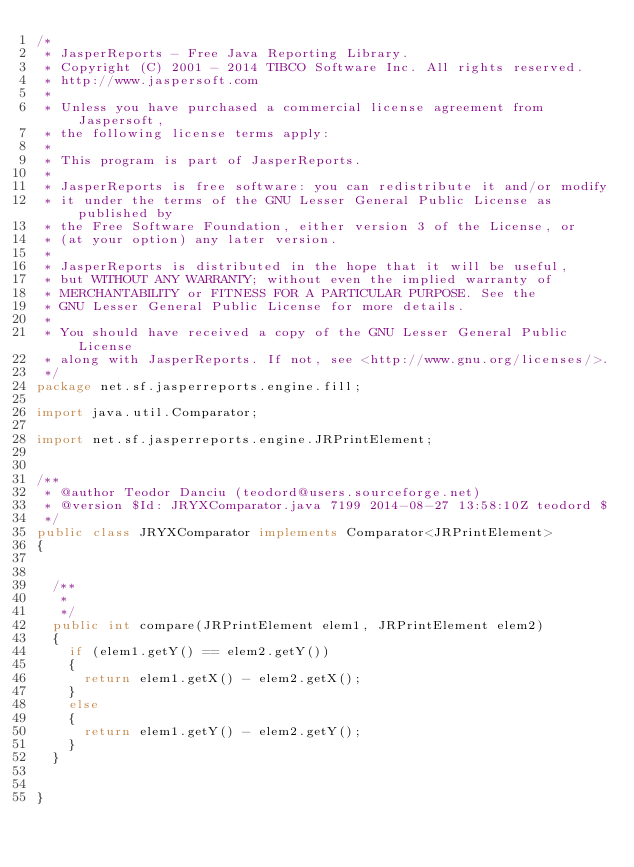Convert code to text. <code><loc_0><loc_0><loc_500><loc_500><_Java_>/*
 * JasperReports - Free Java Reporting Library.
 * Copyright (C) 2001 - 2014 TIBCO Software Inc. All rights reserved.
 * http://www.jaspersoft.com
 *
 * Unless you have purchased a commercial license agreement from Jaspersoft,
 * the following license terms apply:
 *
 * This program is part of JasperReports.
 *
 * JasperReports is free software: you can redistribute it and/or modify
 * it under the terms of the GNU Lesser General Public License as published by
 * the Free Software Foundation, either version 3 of the License, or
 * (at your option) any later version.
 *
 * JasperReports is distributed in the hope that it will be useful,
 * but WITHOUT ANY WARRANTY; without even the implied warranty of
 * MERCHANTABILITY or FITNESS FOR A PARTICULAR PURPOSE. See the
 * GNU Lesser General Public License for more details.
 *
 * You should have received a copy of the GNU Lesser General Public License
 * along with JasperReports. If not, see <http://www.gnu.org/licenses/>.
 */
package net.sf.jasperreports.engine.fill;

import java.util.Comparator;

import net.sf.jasperreports.engine.JRPrintElement;


/**
 * @author Teodor Danciu (teodord@users.sourceforge.net)
 * @version $Id: JRYXComparator.java 7199 2014-08-27 13:58:10Z teodord $
 */
public class JRYXComparator implements Comparator<JRPrintElement>
{
	

	/**
	 *
	 */
	public int compare(JRPrintElement elem1, JRPrintElement elem2)
	{
		if (elem1.getY() == elem2.getY())
		{
			return elem1.getX() - elem2.getX();
		}
		else
		{
			return elem1.getY() - elem2.getY();
		}
	}


}
</code> 